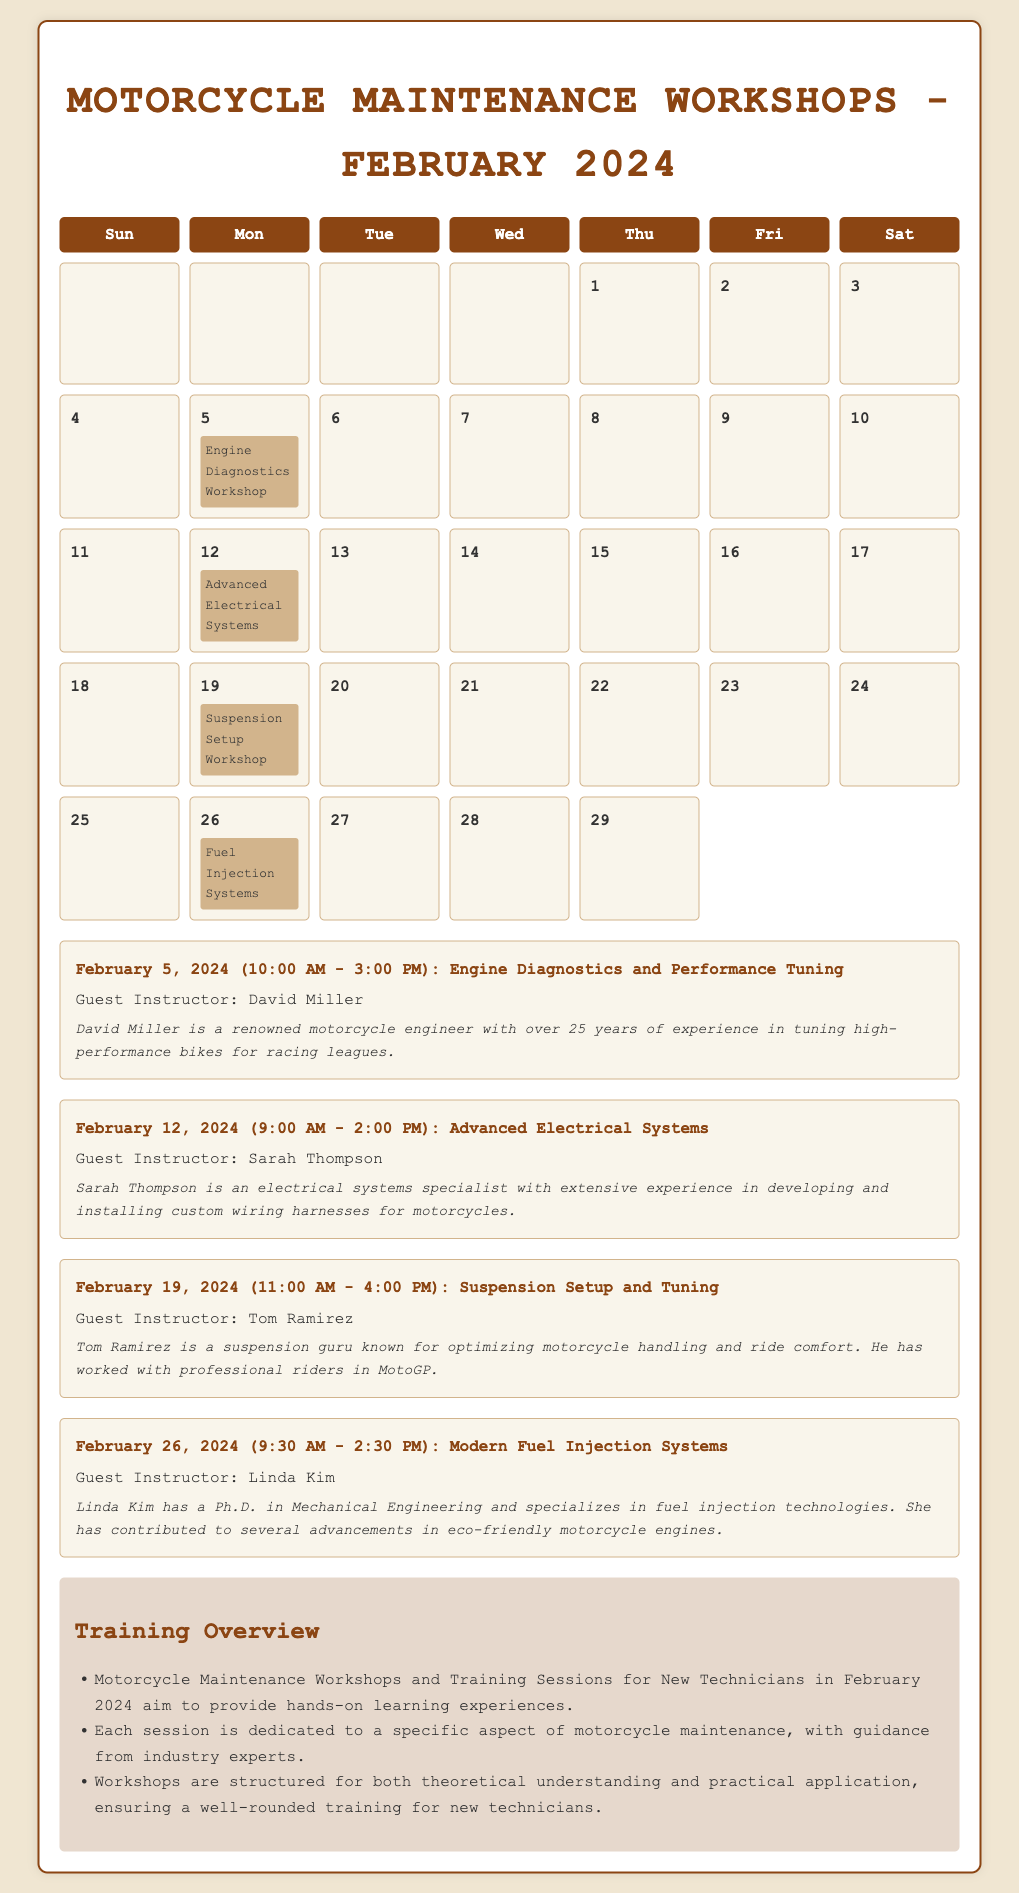what workshop is on February 5, 2024? The document lists the "Engine Diagnostics and Performance Tuning" workshop on February 5, 2024.
Answer: Engine Diagnostics and Performance Tuning who is the guest instructor for the Suspension Setup Workshop? The guest instructor for the Suspension Setup Workshop on February 19, 2024, is Tom Ramirez.
Answer: Tom Ramirez what time does the Advanced Electrical Systems workshop start? The Advanced Electrical Systems workshop on February 12, 2024, begins at 9:00 AM.
Answer: 9:00 AM how many workshops are scheduled for February 2024? There are four workshops scheduled in February 2024.
Answer: Four what is the main focus of the training overview? The training overview emphasizes hands-on learning experiences for new technicians in motorcycle maintenance.
Answer: Hands-on learning experiences which workshop has a guest instructor with a Ph.D. in Mechanical Engineering? The workshop on February 26, 2024, features Linda Kim, who has a Ph.D. in Mechanical Engineering.
Answer: February 26, 2024 what is the date of the Fuel Injection Systems workshop? The Fuel Injection Systems workshop is scheduled for February 26, 2024.
Answer: February 26, 2024 how long is the Suspension Setup and Tuning workshop? The Suspension Setup and Tuning workshop on February 19, 2024, lasts for five hours.
Answer: Five hours 